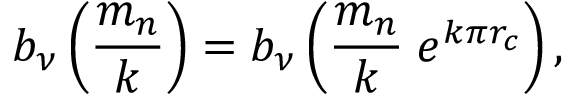<formula> <loc_0><loc_0><loc_500><loc_500>b _ { \nu } \left ( \frac { m _ { n } } { k } \right ) = b _ { \nu } \left ( \frac { m _ { n } } { k } \, e ^ { k \pi r _ { c } } \right ) ,</formula> 